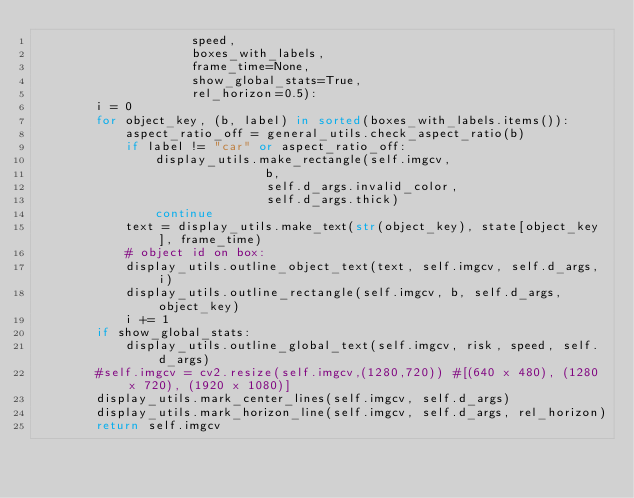Convert code to text. <code><loc_0><loc_0><loc_500><loc_500><_Python_>                     speed,
                     boxes_with_labels,
                     frame_time=None,
                     show_global_stats=True,
                     rel_horizon=0.5):
        i = 0
        for object_key, (b, label) in sorted(boxes_with_labels.items()):
            aspect_ratio_off = general_utils.check_aspect_ratio(b)
            if label != "car" or aspect_ratio_off:
                display_utils.make_rectangle(self.imgcv,
                               b,
                               self.d_args.invalid_color,
                               self.d_args.thick)
                continue
            text = display_utils.make_text(str(object_key), state[object_key], frame_time)
            # object id on box:
            display_utils.outline_object_text(text, self.imgcv, self.d_args, i)
            display_utils.outline_rectangle(self.imgcv, b, self.d_args, object_key)
            i += 1
        if show_global_stats:
            display_utils.outline_global_text(self.imgcv, risk, speed, self.d_args)
        #self.imgcv = cv2.resize(self.imgcv,(1280,720)) #[(640 x 480), (1280 x 720), (1920 x 1080)]
        display_utils.mark_center_lines(self.imgcv, self.d_args)
        display_utils.mark_horizon_line(self.imgcv, self.d_args, rel_horizon)
        return self.imgcv
</code> 